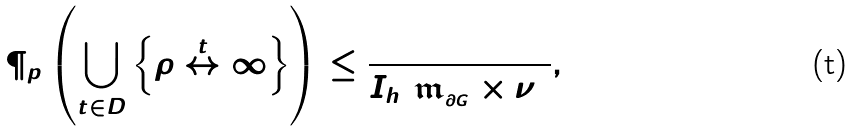Convert formula to latex. <formula><loc_0><loc_0><loc_500><loc_500>\P _ { p } \left ( \bigcup _ { t \in D } \left \{ \rho \stackrel { t } { \leftrightarrow } \infty \right \} \right ) \leq \frac { 5 1 2 } { I _ { h } ( \mathfrak { m } _ { _ { \partial G } } \times \nu ) } ,</formula> 